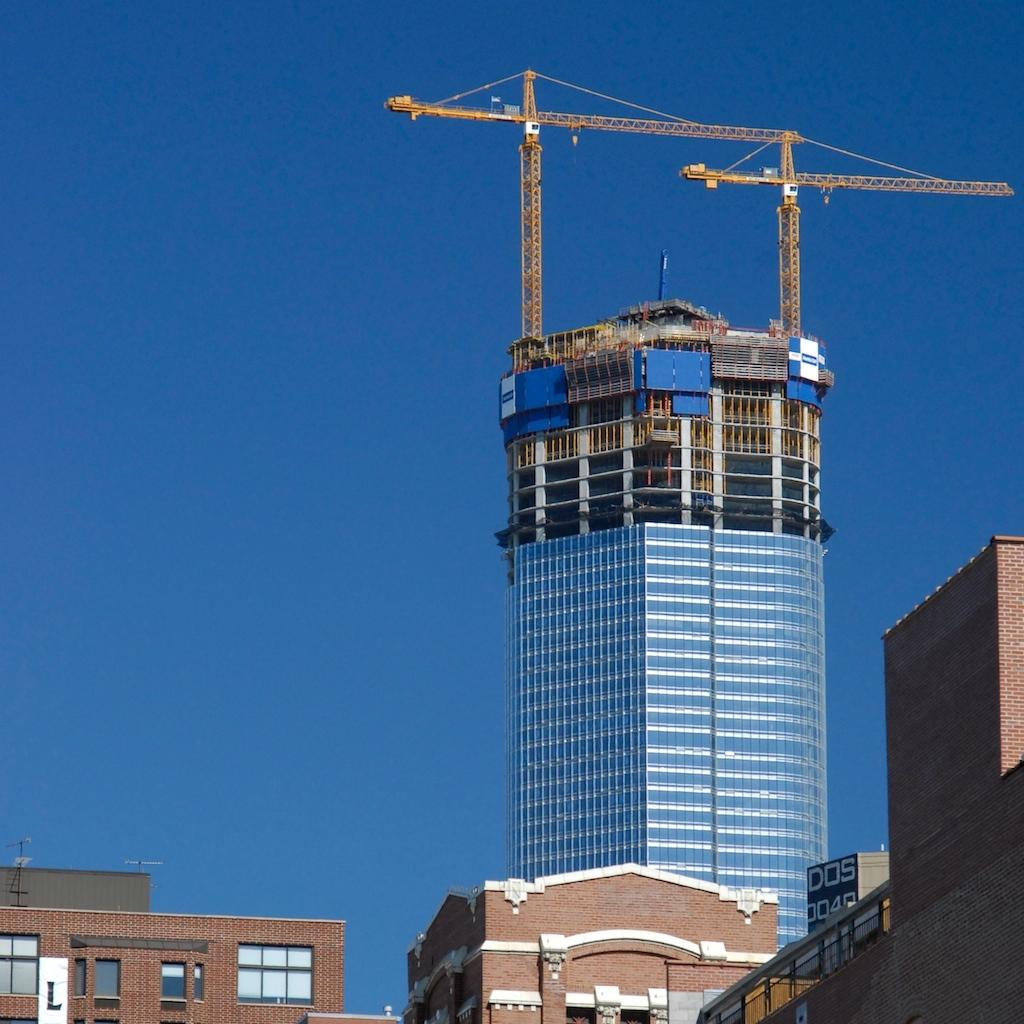What type of structures are present in the image? There are buildings in the image. Are there any specific features on top of the buildings? Yes, there are two cranes on top of the buildings. What can be seen in the sky in the image? The sky is clear and visible at the top of the image. What type of bait is being used to attract the destruction in the image? There is no bait or destruction present in the image; it features buildings with cranes on top and a clear sky. Can you tell me how many forks are visible in the image? There are no forks present in the image. 